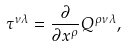<formula> <loc_0><loc_0><loc_500><loc_500>\tau ^ { \nu \lambda } = \frac { \partial } { \partial x ^ { \rho } } Q ^ { \rho \nu \lambda } ,</formula> 